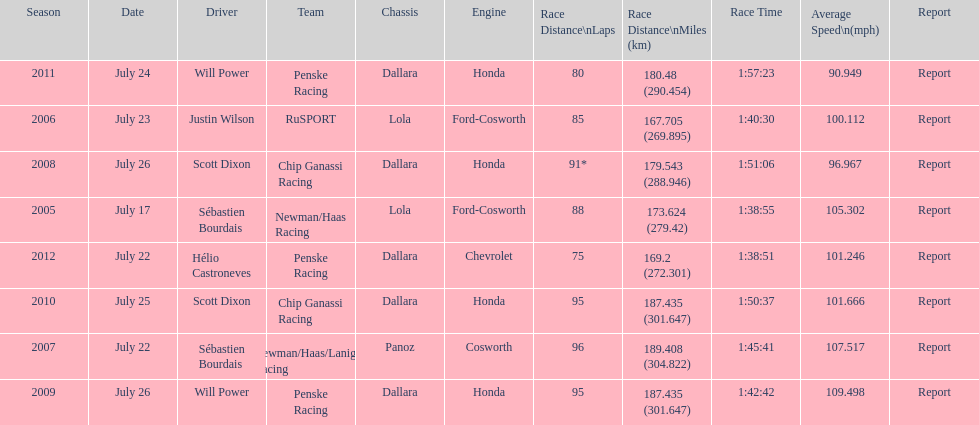Would you be able to parse every entry in this table? {'header': ['Season', 'Date', 'Driver', 'Team', 'Chassis', 'Engine', 'Race Distance\\nLaps', 'Race Distance\\nMiles (km)', 'Race Time', 'Average Speed\\n(mph)', 'Report'], 'rows': [['2011', 'July 24', 'Will Power', 'Penske Racing', 'Dallara', 'Honda', '80', '180.48 (290.454)', '1:57:23', '90.949', 'Report'], ['2006', 'July 23', 'Justin Wilson', 'RuSPORT', 'Lola', 'Ford-Cosworth', '85', '167.705 (269.895)', '1:40:30', '100.112', 'Report'], ['2008', 'July 26', 'Scott Dixon', 'Chip Ganassi Racing', 'Dallara', 'Honda', '91*', '179.543 (288.946)', '1:51:06', '96.967', 'Report'], ['2005', 'July 17', 'Sébastien Bourdais', 'Newman/Haas Racing', 'Lola', 'Ford-Cosworth', '88', '173.624 (279.42)', '1:38:55', '105.302', 'Report'], ['2012', 'July 22', 'Hélio Castroneves', 'Penske Racing', 'Dallara', 'Chevrolet', '75', '169.2 (272.301)', '1:38:51', '101.246', 'Report'], ['2010', 'July 25', 'Scott Dixon', 'Chip Ganassi Racing', 'Dallara', 'Honda', '95', '187.435 (301.647)', '1:50:37', '101.666', 'Report'], ['2007', 'July 22', 'Sébastien Bourdais', 'Newman/Haas/Lanigan Racing', 'Panoz', 'Cosworth', '96', '189.408 (304.822)', '1:45:41', '107.517', 'Report'], ['2009', 'July 26', 'Will Power', 'Penske Racing', 'Dallara', 'Honda', '95', '187.435 (301.647)', '1:42:42', '109.498', 'Report']]} How many flags other than france (the first flag) are represented? 3. 